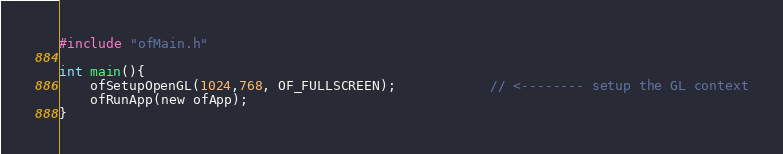Convert code to text. <code><loc_0><loc_0><loc_500><loc_500><_ObjectiveC_>#include "ofMain.h"

int main(){
	ofSetupOpenGL(1024,768, OF_FULLSCREEN);			// <-------- setup the GL context
	ofRunApp(new ofApp);
}
</code> 